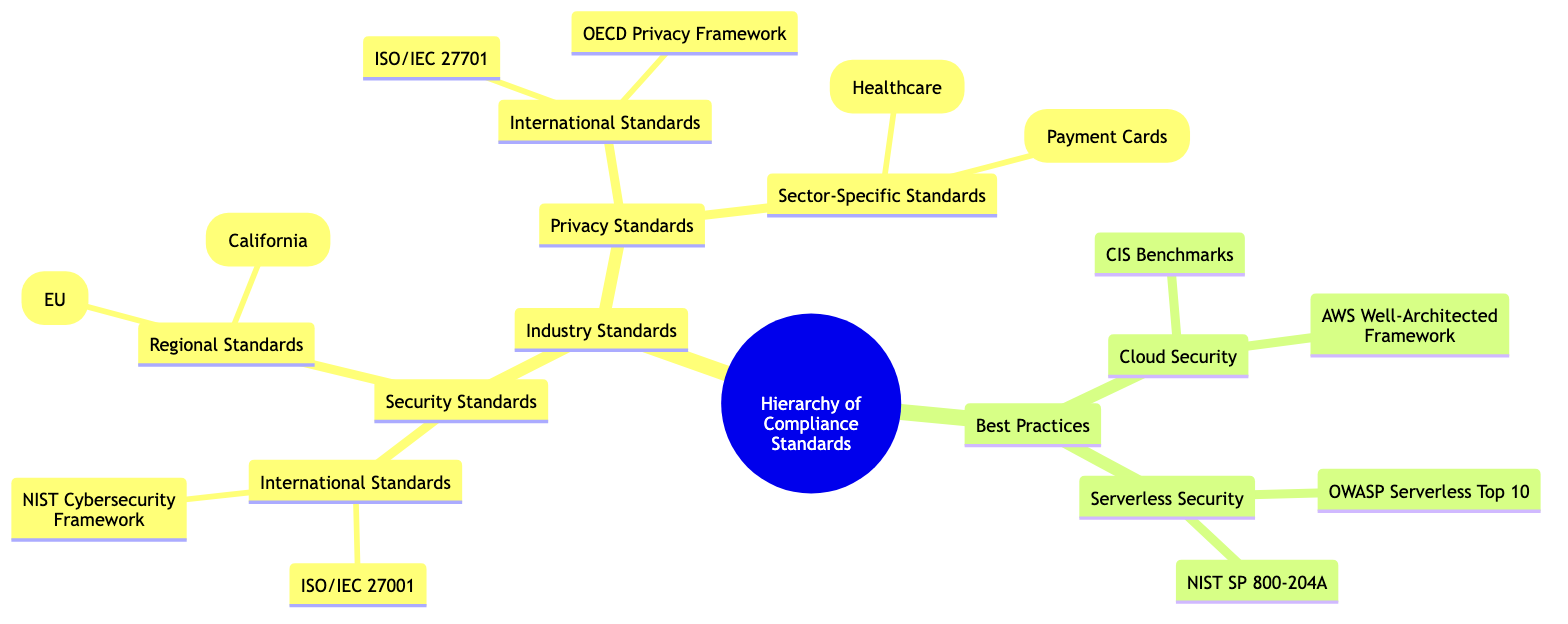What is the top-level category in the hierarchy? The diagram shows "Hierarchy of Compliance Standards" at the top level as the main node, categorizing all subsequent standards and practices.
Answer: Hierarchy of Compliance Standards How many types of standards are under Industry Standards? The diagram lists two types of standards under Industry Standards: Security Standards and Privacy Standards, which can be counted directly.
Answer: 2 What compliance standard falls under Regional Standards? GDPR (EU) is specifically mentioned under Regional Standards, making it the identifiable standard within this subgroup.
Answer: GDPR (EU) Which document is listed as a sector-specific standard? HIPAA (Healthcare) is categorized as a sector-specific standard, defined within the Privacy Standards node.
Answer: HIPAA (Healthcare) What are the two categories under Best Practices? The diagram clearly distinguishes two main categories under Best Practices: Cloud Security and Serverless Security, listed horizontally from the Best Practices node.
Answer: Cloud Security, Serverless Security How many international security standards are listed? Under Security Standards and specifically in International Standards, there are two documented, namely ISO/IEC 27001 and NIST Cybersecurity Framework, which can be counted.
Answer: 2 Which framework is mentioned in Serverless Security? Among the standards provided in Serverless Security, one explicitly identified is NIST SP 800-204A, making it a recognizable document in this category.
Answer: NIST SP 800-204A What is the lowest level of compliance standard in the tree? The lowest level of compliance standards in the tree consists of specific standards that don’t break down into further subcategories, like ISO/IEC 27001, thus indicating it as the base or leaf node of the hierarchy.
Answer: ISO/IEC 27001 What is one of the best practices listed under Cloud Security? The diagram directly lists CIS Benchmarks as a suitable best practice under the broader category of Cloud Security.
Answer: CIS Benchmarks How many total sector-specific standards are identified? Within the Privacy Standards section, there are two distinct sector-specific standards mentioned: HIPAA (Healthcare) and PCI DSS (Payment Cards), both of which are countable elements.
Answer: 2 